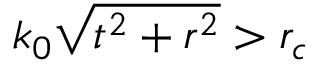<formula> <loc_0><loc_0><loc_500><loc_500>k _ { 0 } \sqrt { t ^ { 2 } + r ^ { 2 } } > r _ { c }</formula> 